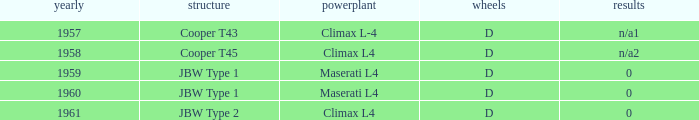What is the engine for a vehicle in 1960? Maserati L4. 